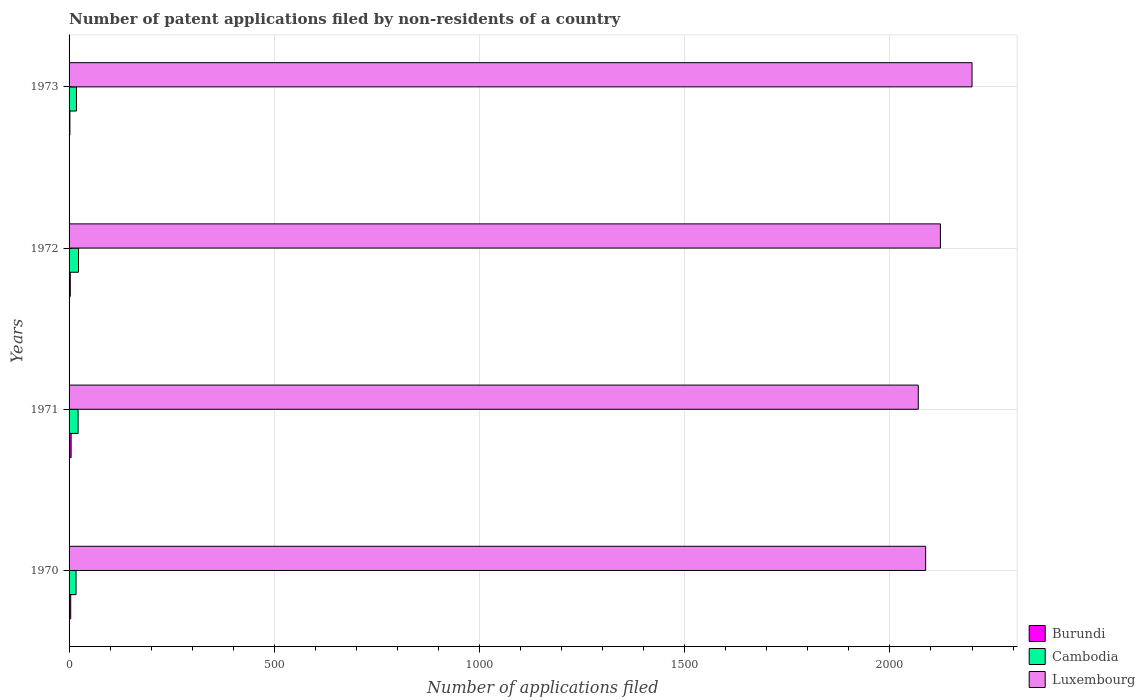How many different coloured bars are there?
Ensure brevity in your answer.  3. How many groups of bars are there?
Give a very brief answer. 4. Are the number of bars per tick equal to the number of legend labels?
Provide a succinct answer. Yes. How many bars are there on the 4th tick from the bottom?
Ensure brevity in your answer.  3. What is the number of applications filed in Luxembourg in 1971?
Ensure brevity in your answer.  2069. Across all years, what is the maximum number of applications filed in Burundi?
Provide a short and direct response. 5. In which year was the number of applications filed in Burundi maximum?
Offer a very short reply. 1971. In which year was the number of applications filed in Luxembourg minimum?
Give a very brief answer. 1971. What is the total number of applications filed in Burundi in the graph?
Offer a terse response. 14. What is the difference between the number of applications filed in Luxembourg in 1971 and that in 1972?
Offer a very short reply. -54. What is the difference between the number of applications filed in Cambodia in 1973 and the number of applications filed in Luxembourg in 1972?
Offer a terse response. -2105. What is the average number of applications filed in Luxembourg per year?
Your answer should be very brief. 2119.75. In the year 1970, what is the difference between the number of applications filed in Burundi and number of applications filed in Cambodia?
Your answer should be very brief. -13. What is the ratio of the number of applications filed in Cambodia in 1972 to that in 1973?
Offer a very short reply. 1.28. Is the difference between the number of applications filed in Burundi in 1970 and 1971 greater than the difference between the number of applications filed in Cambodia in 1970 and 1971?
Your response must be concise. Yes. What is the difference between the highest and the second highest number of applications filed in Luxembourg?
Give a very brief answer. 77. What is the difference between the highest and the lowest number of applications filed in Luxembourg?
Give a very brief answer. 131. In how many years, is the number of applications filed in Luxembourg greater than the average number of applications filed in Luxembourg taken over all years?
Your answer should be very brief. 2. What does the 1st bar from the top in 1972 represents?
Offer a very short reply. Luxembourg. What does the 2nd bar from the bottom in 1972 represents?
Provide a succinct answer. Cambodia. Are all the bars in the graph horizontal?
Offer a very short reply. Yes. Are the values on the major ticks of X-axis written in scientific E-notation?
Give a very brief answer. No. Does the graph contain grids?
Make the answer very short. Yes. How many legend labels are there?
Offer a very short reply. 3. How are the legend labels stacked?
Make the answer very short. Vertical. What is the title of the graph?
Offer a very short reply. Number of patent applications filed by non-residents of a country. What is the label or title of the X-axis?
Provide a succinct answer. Number of applications filed. What is the Number of applications filed in Cambodia in 1970?
Provide a short and direct response. 17. What is the Number of applications filed of Luxembourg in 1970?
Offer a very short reply. 2087. What is the Number of applications filed of Burundi in 1971?
Ensure brevity in your answer.  5. What is the Number of applications filed in Cambodia in 1971?
Offer a very short reply. 22. What is the Number of applications filed of Luxembourg in 1971?
Keep it short and to the point. 2069. What is the Number of applications filed in Burundi in 1972?
Provide a succinct answer. 3. What is the Number of applications filed of Cambodia in 1972?
Give a very brief answer. 23. What is the Number of applications filed in Luxembourg in 1972?
Offer a very short reply. 2123. What is the Number of applications filed of Burundi in 1973?
Provide a short and direct response. 2. What is the Number of applications filed in Luxembourg in 1973?
Make the answer very short. 2200. Across all years, what is the maximum Number of applications filed of Burundi?
Offer a very short reply. 5. Across all years, what is the maximum Number of applications filed of Cambodia?
Offer a very short reply. 23. Across all years, what is the maximum Number of applications filed in Luxembourg?
Offer a terse response. 2200. Across all years, what is the minimum Number of applications filed of Cambodia?
Offer a very short reply. 17. Across all years, what is the minimum Number of applications filed of Luxembourg?
Make the answer very short. 2069. What is the total Number of applications filed in Burundi in the graph?
Keep it short and to the point. 14. What is the total Number of applications filed in Luxembourg in the graph?
Give a very brief answer. 8479. What is the difference between the Number of applications filed of Burundi in 1970 and that in 1971?
Give a very brief answer. -1. What is the difference between the Number of applications filed in Cambodia in 1970 and that in 1972?
Keep it short and to the point. -6. What is the difference between the Number of applications filed in Luxembourg in 1970 and that in 1972?
Your answer should be compact. -36. What is the difference between the Number of applications filed of Luxembourg in 1970 and that in 1973?
Ensure brevity in your answer.  -113. What is the difference between the Number of applications filed in Cambodia in 1971 and that in 1972?
Provide a short and direct response. -1. What is the difference between the Number of applications filed of Luxembourg in 1971 and that in 1972?
Your answer should be compact. -54. What is the difference between the Number of applications filed in Cambodia in 1971 and that in 1973?
Provide a succinct answer. 4. What is the difference between the Number of applications filed in Luxembourg in 1971 and that in 1973?
Your answer should be very brief. -131. What is the difference between the Number of applications filed of Burundi in 1972 and that in 1973?
Offer a very short reply. 1. What is the difference between the Number of applications filed of Cambodia in 1972 and that in 1973?
Make the answer very short. 5. What is the difference between the Number of applications filed of Luxembourg in 1972 and that in 1973?
Provide a succinct answer. -77. What is the difference between the Number of applications filed of Burundi in 1970 and the Number of applications filed of Luxembourg in 1971?
Your answer should be very brief. -2065. What is the difference between the Number of applications filed in Cambodia in 1970 and the Number of applications filed in Luxembourg in 1971?
Your answer should be very brief. -2052. What is the difference between the Number of applications filed in Burundi in 1970 and the Number of applications filed in Luxembourg in 1972?
Your answer should be compact. -2119. What is the difference between the Number of applications filed of Cambodia in 1970 and the Number of applications filed of Luxembourg in 1972?
Your response must be concise. -2106. What is the difference between the Number of applications filed in Burundi in 1970 and the Number of applications filed in Luxembourg in 1973?
Ensure brevity in your answer.  -2196. What is the difference between the Number of applications filed of Cambodia in 1970 and the Number of applications filed of Luxembourg in 1973?
Make the answer very short. -2183. What is the difference between the Number of applications filed in Burundi in 1971 and the Number of applications filed in Luxembourg in 1972?
Give a very brief answer. -2118. What is the difference between the Number of applications filed of Cambodia in 1971 and the Number of applications filed of Luxembourg in 1972?
Offer a very short reply. -2101. What is the difference between the Number of applications filed in Burundi in 1971 and the Number of applications filed in Cambodia in 1973?
Give a very brief answer. -13. What is the difference between the Number of applications filed of Burundi in 1971 and the Number of applications filed of Luxembourg in 1973?
Your answer should be very brief. -2195. What is the difference between the Number of applications filed of Cambodia in 1971 and the Number of applications filed of Luxembourg in 1973?
Provide a succinct answer. -2178. What is the difference between the Number of applications filed in Burundi in 1972 and the Number of applications filed in Cambodia in 1973?
Offer a very short reply. -15. What is the difference between the Number of applications filed in Burundi in 1972 and the Number of applications filed in Luxembourg in 1973?
Give a very brief answer. -2197. What is the difference between the Number of applications filed in Cambodia in 1972 and the Number of applications filed in Luxembourg in 1973?
Offer a terse response. -2177. What is the average Number of applications filed of Cambodia per year?
Give a very brief answer. 20. What is the average Number of applications filed in Luxembourg per year?
Your answer should be compact. 2119.75. In the year 1970, what is the difference between the Number of applications filed in Burundi and Number of applications filed in Cambodia?
Offer a terse response. -13. In the year 1970, what is the difference between the Number of applications filed of Burundi and Number of applications filed of Luxembourg?
Provide a short and direct response. -2083. In the year 1970, what is the difference between the Number of applications filed in Cambodia and Number of applications filed in Luxembourg?
Give a very brief answer. -2070. In the year 1971, what is the difference between the Number of applications filed of Burundi and Number of applications filed of Luxembourg?
Make the answer very short. -2064. In the year 1971, what is the difference between the Number of applications filed of Cambodia and Number of applications filed of Luxembourg?
Offer a terse response. -2047. In the year 1972, what is the difference between the Number of applications filed in Burundi and Number of applications filed in Luxembourg?
Provide a succinct answer. -2120. In the year 1972, what is the difference between the Number of applications filed in Cambodia and Number of applications filed in Luxembourg?
Offer a very short reply. -2100. In the year 1973, what is the difference between the Number of applications filed in Burundi and Number of applications filed in Luxembourg?
Provide a succinct answer. -2198. In the year 1973, what is the difference between the Number of applications filed in Cambodia and Number of applications filed in Luxembourg?
Ensure brevity in your answer.  -2182. What is the ratio of the Number of applications filed in Cambodia in 1970 to that in 1971?
Give a very brief answer. 0.77. What is the ratio of the Number of applications filed of Luxembourg in 1970 to that in 1971?
Give a very brief answer. 1.01. What is the ratio of the Number of applications filed in Burundi in 1970 to that in 1972?
Make the answer very short. 1.33. What is the ratio of the Number of applications filed in Cambodia in 1970 to that in 1972?
Your answer should be compact. 0.74. What is the ratio of the Number of applications filed in Luxembourg in 1970 to that in 1972?
Offer a very short reply. 0.98. What is the ratio of the Number of applications filed in Burundi in 1970 to that in 1973?
Offer a very short reply. 2. What is the ratio of the Number of applications filed of Cambodia in 1970 to that in 1973?
Make the answer very short. 0.94. What is the ratio of the Number of applications filed of Luxembourg in 1970 to that in 1973?
Offer a terse response. 0.95. What is the ratio of the Number of applications filed of Burundi in 1971 to that in 1972?
Ensure brevity in your answer.  1.67. What is the ratio of the Number of applications filed in Cambodia in 1971 to that in 1972?
Offer a very short reply. 0.96. What is the ratio of the Number of applications filed of Luxembourg in 1971 to that in 1972?
Provide a succinct answer. 0.97. What is the ratio of the Number of applications filed of Cambodia in 1971 to that in 1973?
Give a very brief answer. 1.22. What is the ratio of the Number of applications filed in Luxembourg in 1971 to that in 1973?
Your answer should be very brief. 0.94. What is the ratio of the Number of applications filed of Cambodia in 1972 to that in 1973?
Your response must be concise. 1.28. What is the ratio of the Number of applications filed in Luxembourg in 1972 to that in 1973?
Offer a terse response. 0.96. What is the difference between the highest and the second highest Number of applications filed in Burundi?
Offer a very short reply. 1. What is the difference between the highest and the second highest Number of applications filed in Cambodia?
Your response must be concise. 1. What is the difference between the highest and the second highest Number of applications filed in Luxembourg?
Your response must be concise. 77. What is the difference between the highest and the lowest Number of applications filed in Burundi?
Your answer should be compact. 3. What is the difference between the highest and the lowest Number of applications filed in Luxembourg?
Keep it short and to the point. 131. 